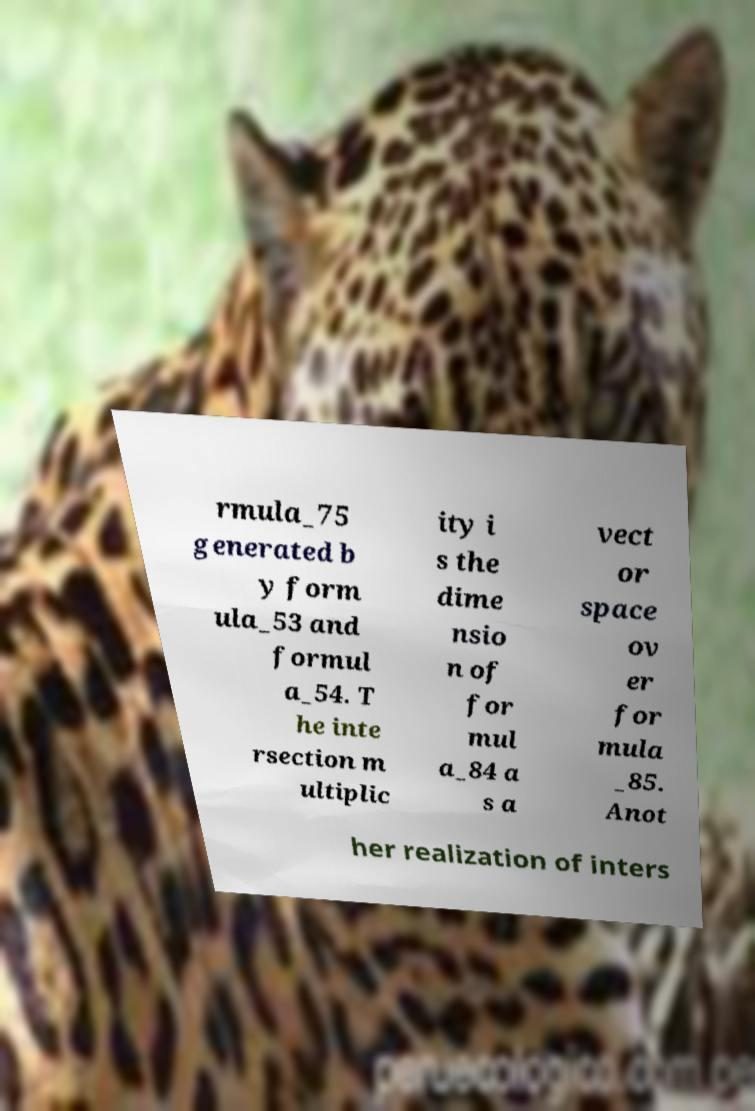Could you extract and type out the text from this image? rmula_75 generated b y form ula_53 and formul a_54. T he inte rsection m ultiplic ity i s the dime nsio n of for mul a_84 a s a vect or space ov er for mula _85. Anot her realization of inters 